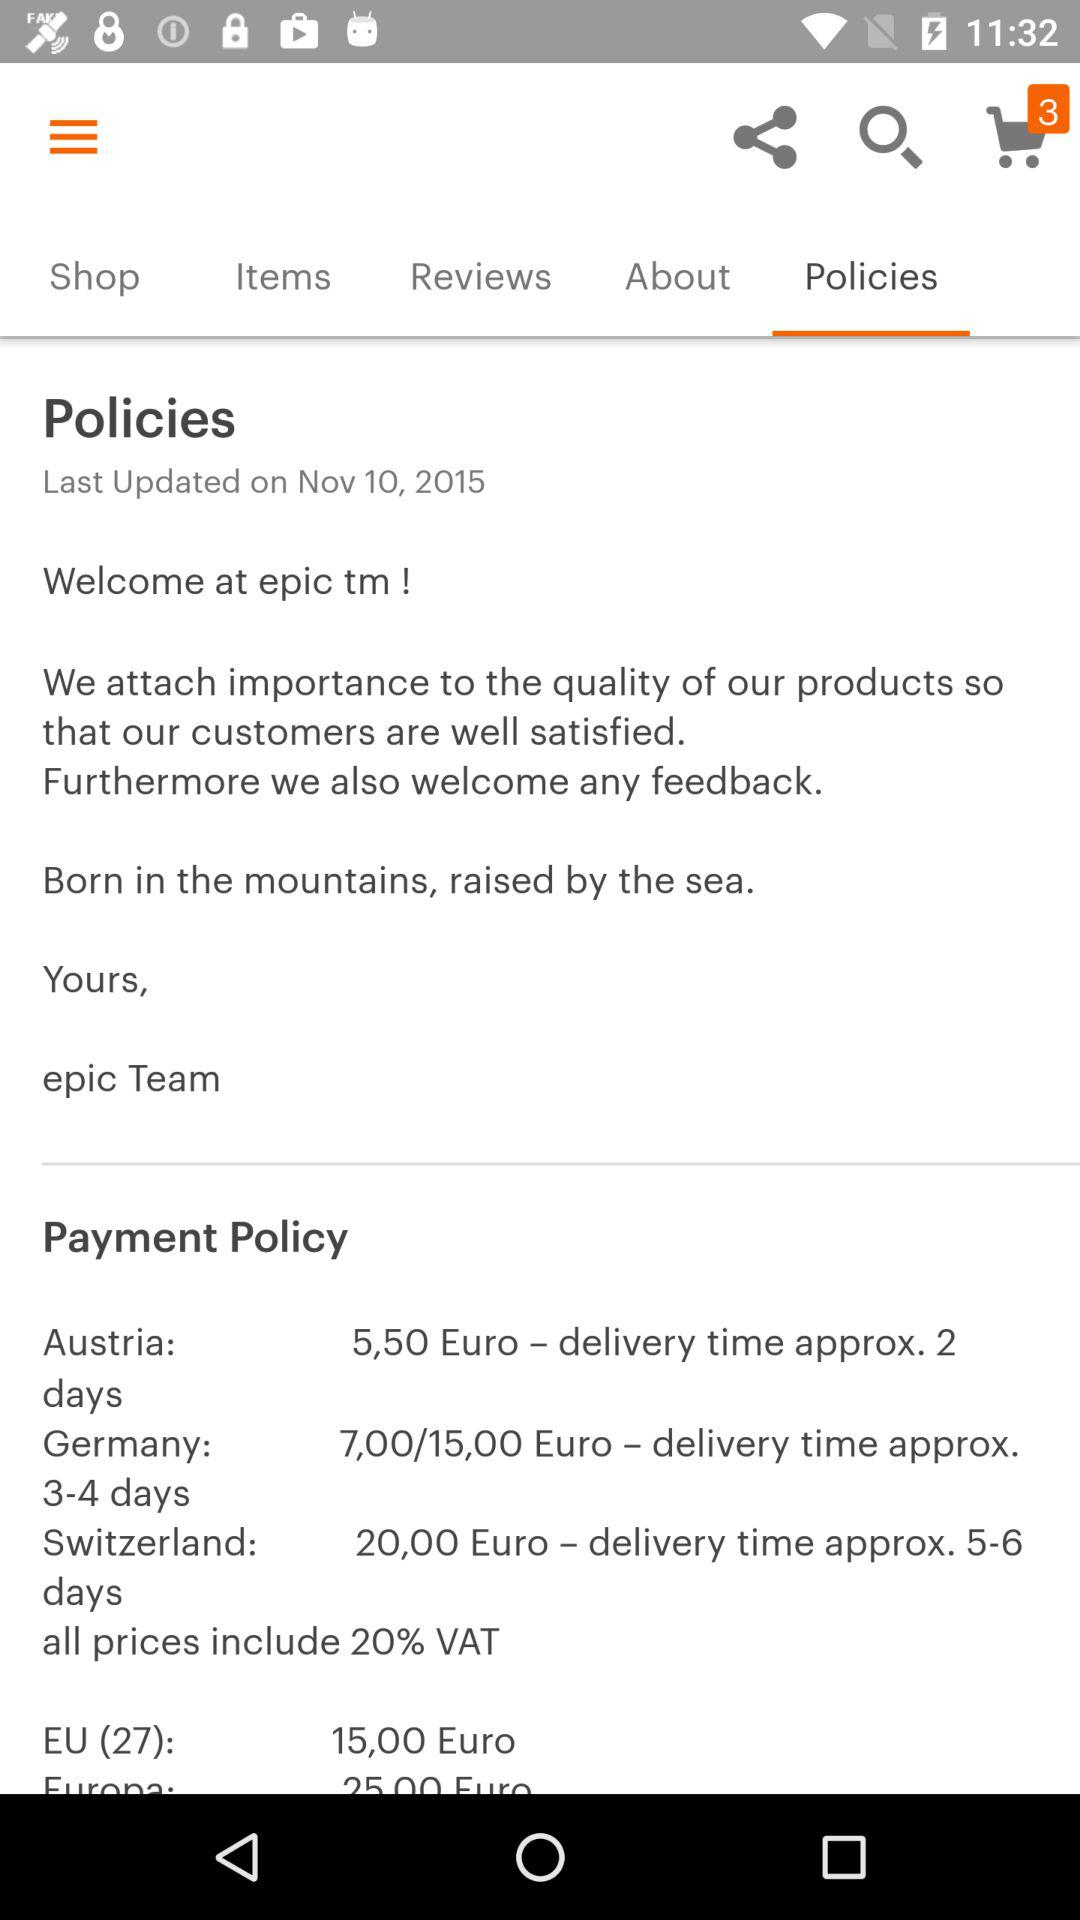How many orders are there in the cart? There are 3 orders. 